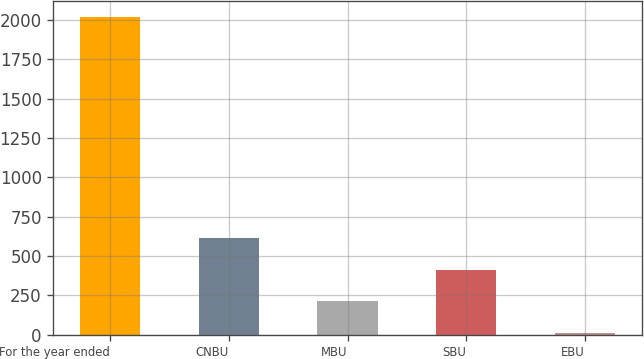Convert chart. <chart><loc_0><loc_0><loc_500><loc_500><bar_chart><fcel>For the year ended<fcel>CNBU<fcel>MBU<fcel>SBU<fcel>EBU<nl><fcel>2017<fcel>614.2<fcel>213.4<fcel>413.8<fcel>13<nl></chart> 